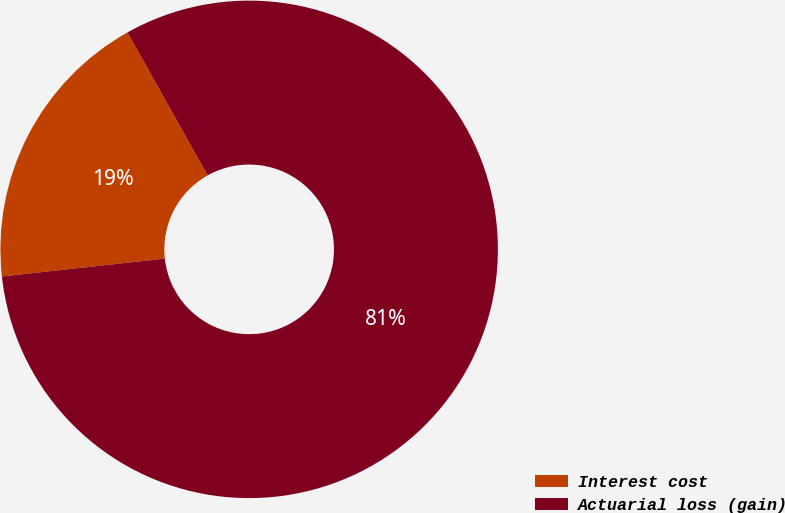Convert chart. <chart><loc_0><loc_0><loc_500><loc_500><pie_chart><fcel>Interest cost<fcel>Actuarial loss (gain)<nl><fcel>18.6%<fcel>81.4%<nl></chart> 